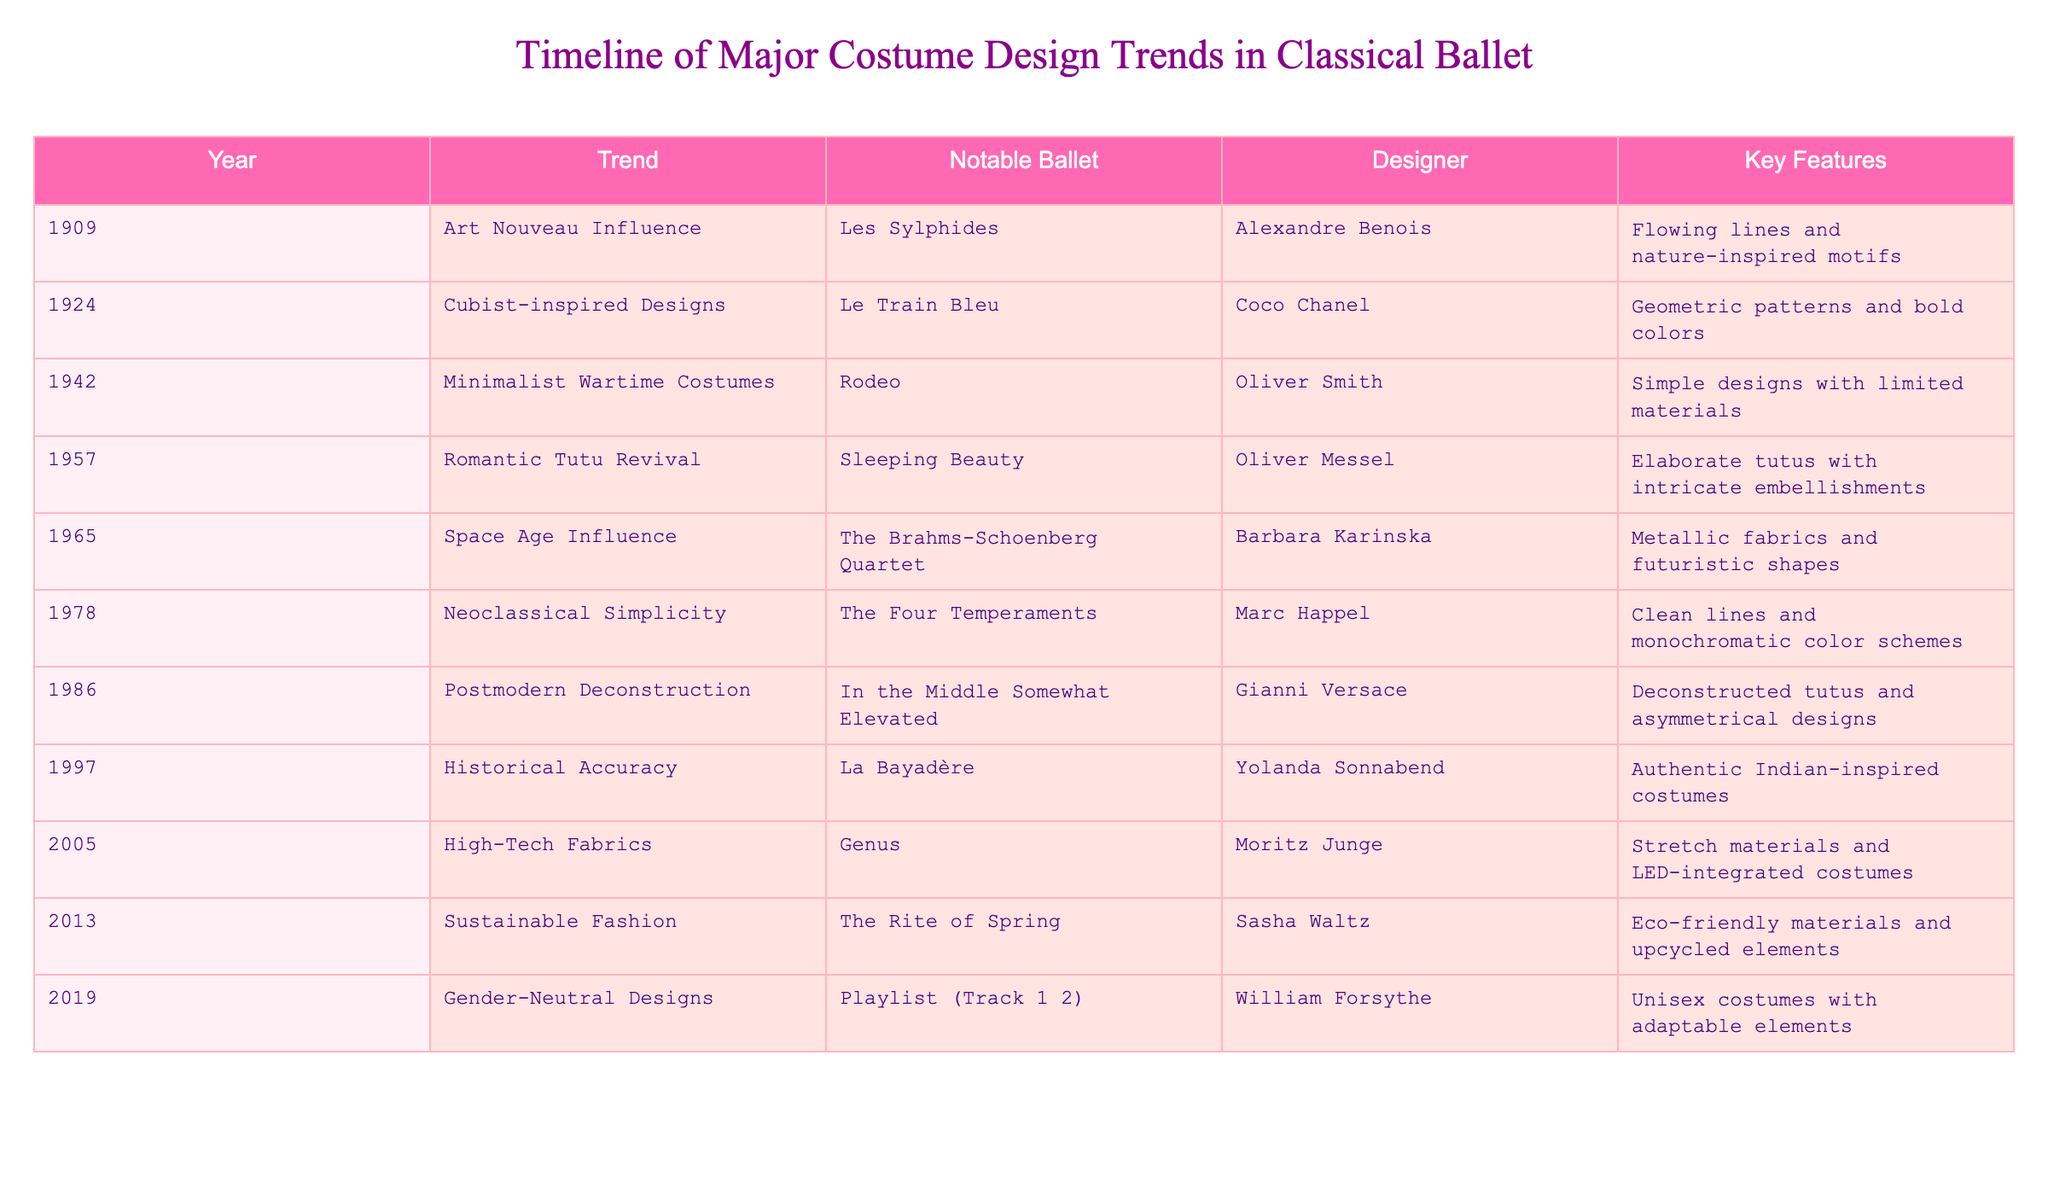What was the trend in costume design in 1924? According to the table, the trend in 1924 was "Cubist-inspired Designs" for the ballet "Le Train Bleu."
Answer: Cubist-inspired Designs Who designed the costumes for "Sleeping Beauty"? The table shows that the designer for "Sleeping Beauty" in the trend of "Romantic Tutu Revival" was Oliver Messel.
Answer: Oliver Messel What notable ballet featured sustainable fashion? The table indicates that "The Rite of Spring" featured sustainable fashion, designed by Sasha Waltz.
Answer: The Rite of Spring How many costume design trends mentioned in the table occurred in the 2000s? The table lists two trends in the 2000s: "High-Tech Fabrics" in 2005 and "Sustainable Fashion" in 2013. Thus, the total count is 2.
Answer: 2 Was there a trend between 1960 and 1980 that emphasized simplicity? The table indicates that the trend "Neoclassical Simplicity," occurring in 1978, did emphasize simplicity.
Answer: Yes What are the key features of the "Space Age Influence" trend? The table provides the key features of the "Space Age Influence" trend as "Metallic fabrics and futuristic shapes."
Answer: Metallic fabrics and futuristic shapes Which costume design trend has the designer Gianni Versace associated with it? According to the table, Gianni Versace designed costumes for the "Postmodern Deconstruction" trend in the ballet "In the Middle Somewhat Elevated."
Answer: Postmodern Deconstruction Which trend from the table has historical accuracy as a key feature? The table states that the trend "Historical Accuracy" was associated with the ballet "La Bayadère," thus confirming this feature.
Answer: La Bayadère What was the latest trend in costume design in the table? The table lists "Gender-Neutral Designs" in 2019 as the latest trend in costume design.
Answer: Gender-Neutral Designs How many trends featured designers associated with "Nature-inspired" aesthetics? The trends "Art Nouveau Influence" in 1909 and "Romantic Tutu Revival" in 1957 are both linked to nature-inspired aesthetics, yielding a total of 2.
Answer: 2 